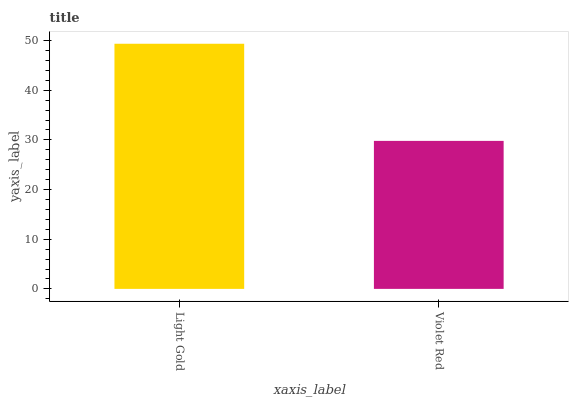Is Violet Red the minimum?
Answer yes or no. Yes. Is Light Gold the maximum?
Answer yes or no. Yes. Is Violet Red the maximum?
Answer yes or no. No. Is Light Gold greater than Violet Red?
Answer yes or no. Yes. Is Violet Red less than Light Gold?
Answer yes or no. Yes. Is Violet Red greater than Light Gold?
Answer yes or no. No. Is Light Gold less than Violet Red?
Answer yes or no. No. Is Light Gold the high median?
Answer yes or no. Yes. Is Violet Red the low median?
Answer yes or no. Yes. Is Violet Red the high median?
Answer yes or no. No. Is Light Gold the low median?
Answer yes or no. No. 